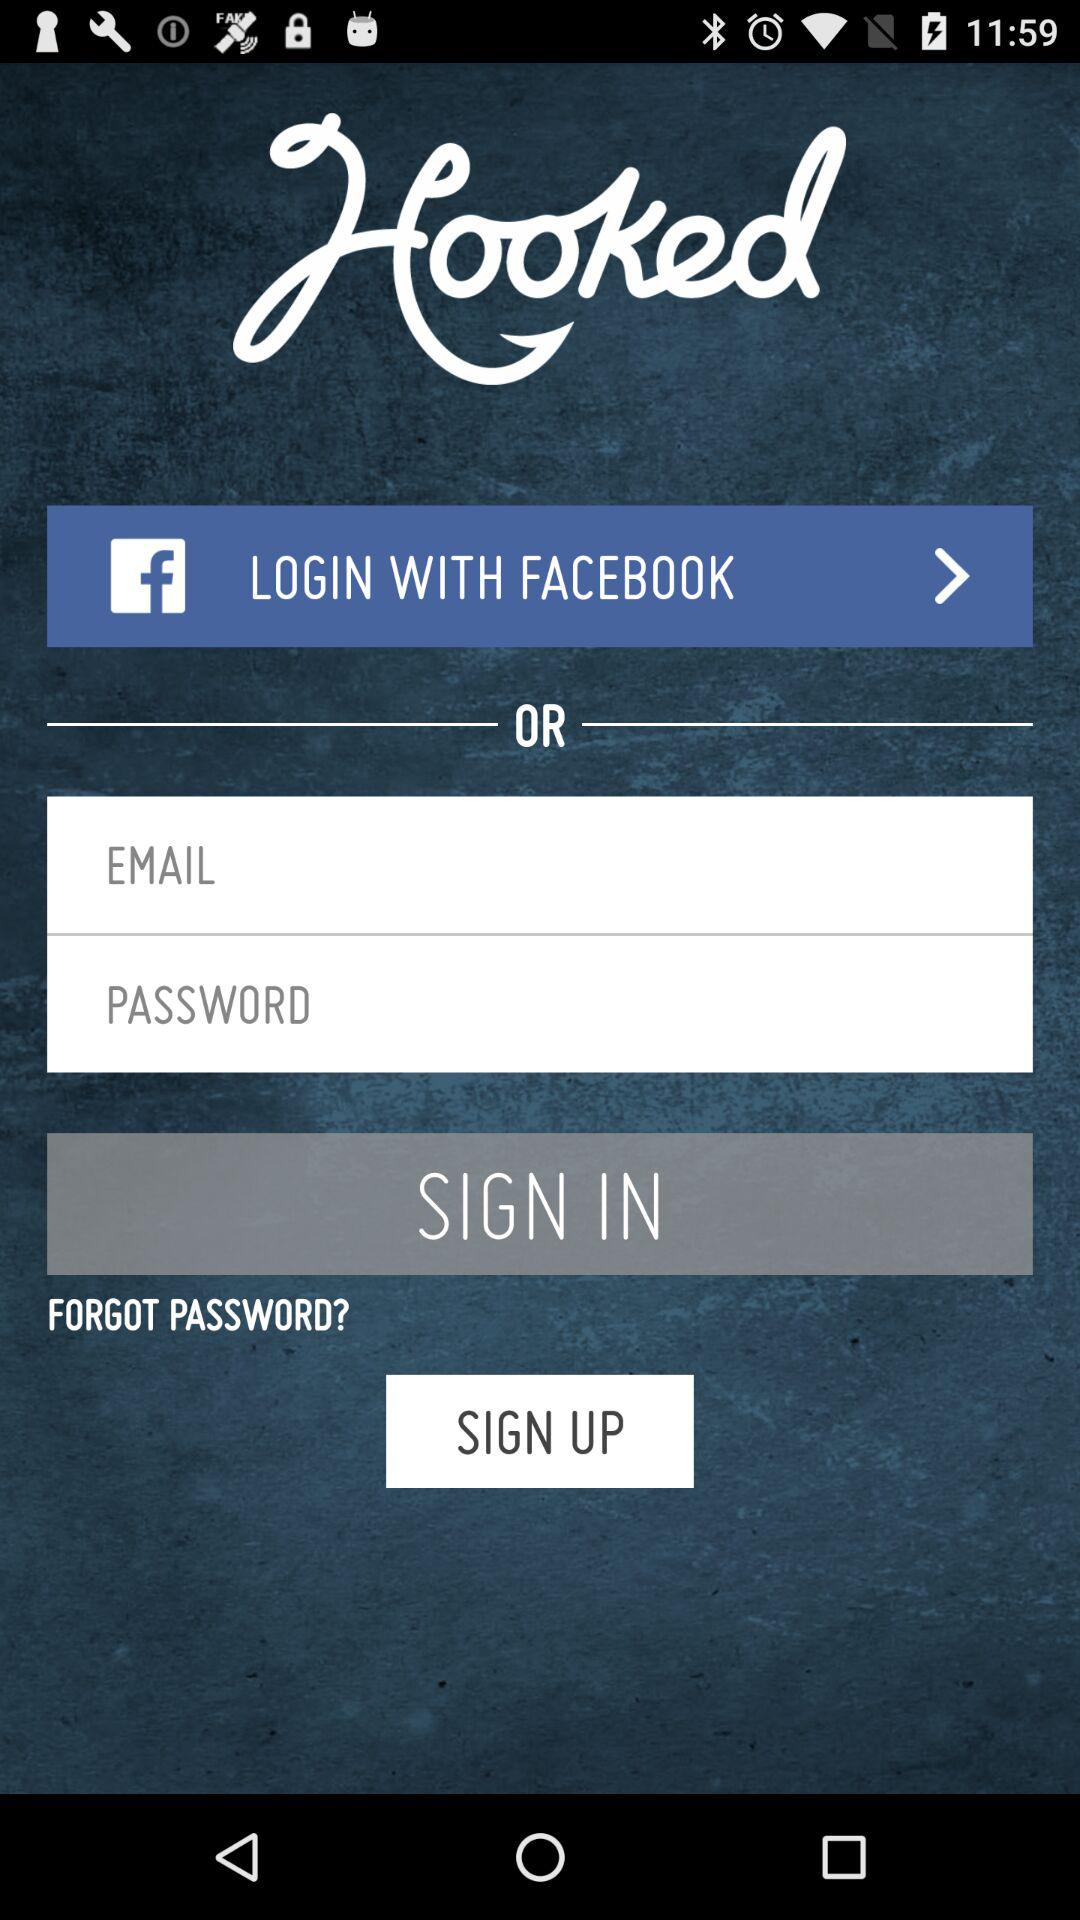Through what application can we login? You can login with "FACEBOOK". 